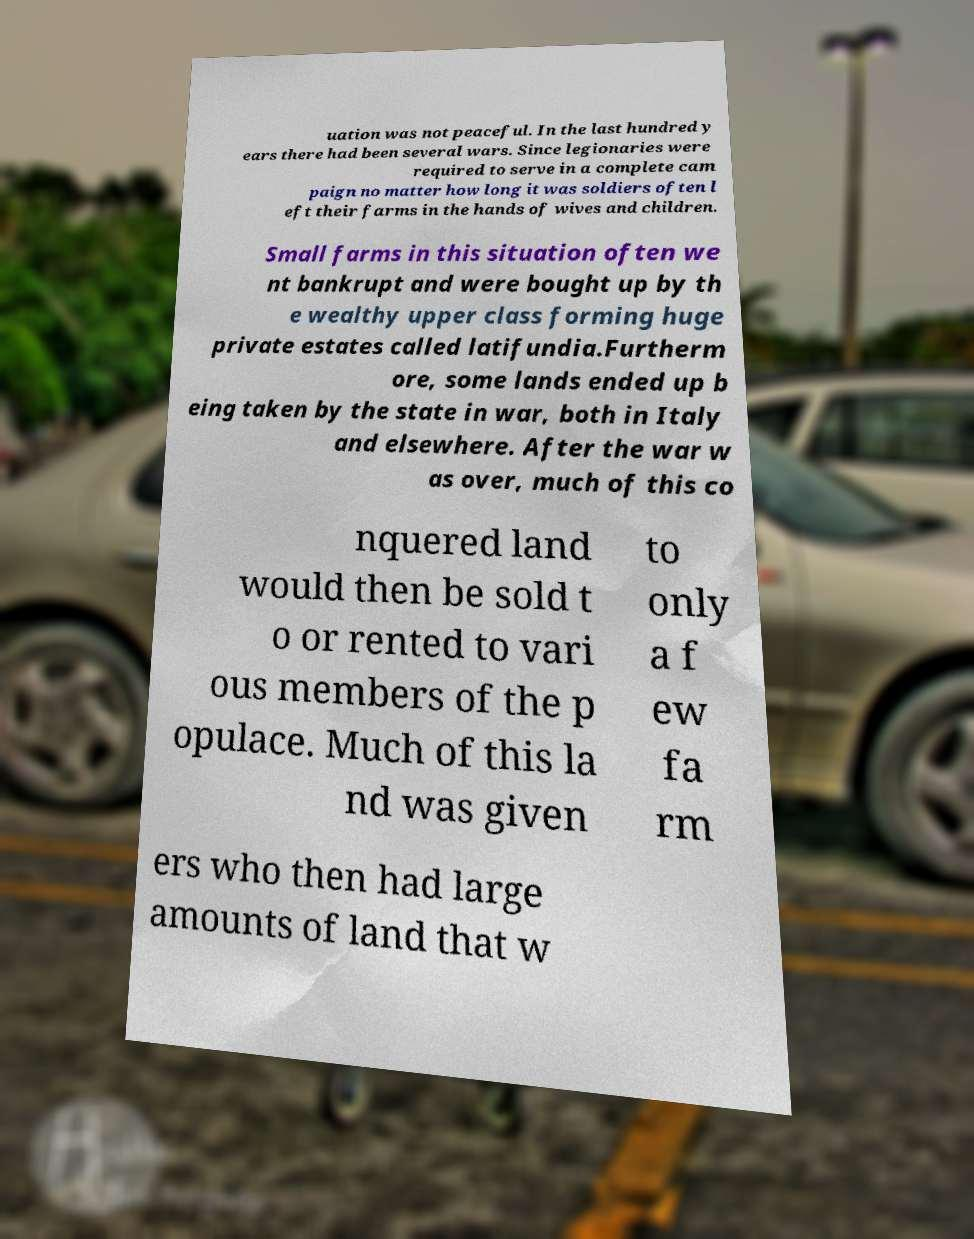Could you extract and type out the text from this image? uation was not peaceful. In the last hundred y ears there had been several wars. Since legionaries were required to serve in a complete cam paign no matter how long it was soldiers often l eft their farms in the hands of wives and children. Small farms in this situation often we nt bankrupt and were bought up by th e wealthy upper class forming huge private estates called latifundia.Furtherm ore, some lands ended up b eing taken by the state in war, both in Italy and elsewhere. After the war w as over, much of this co nquered land would then be sold t o or rented to vari ous members of the p opulace. Much of this la nd was given to only a f ew fa rm ers who then had large amounts of land that w 